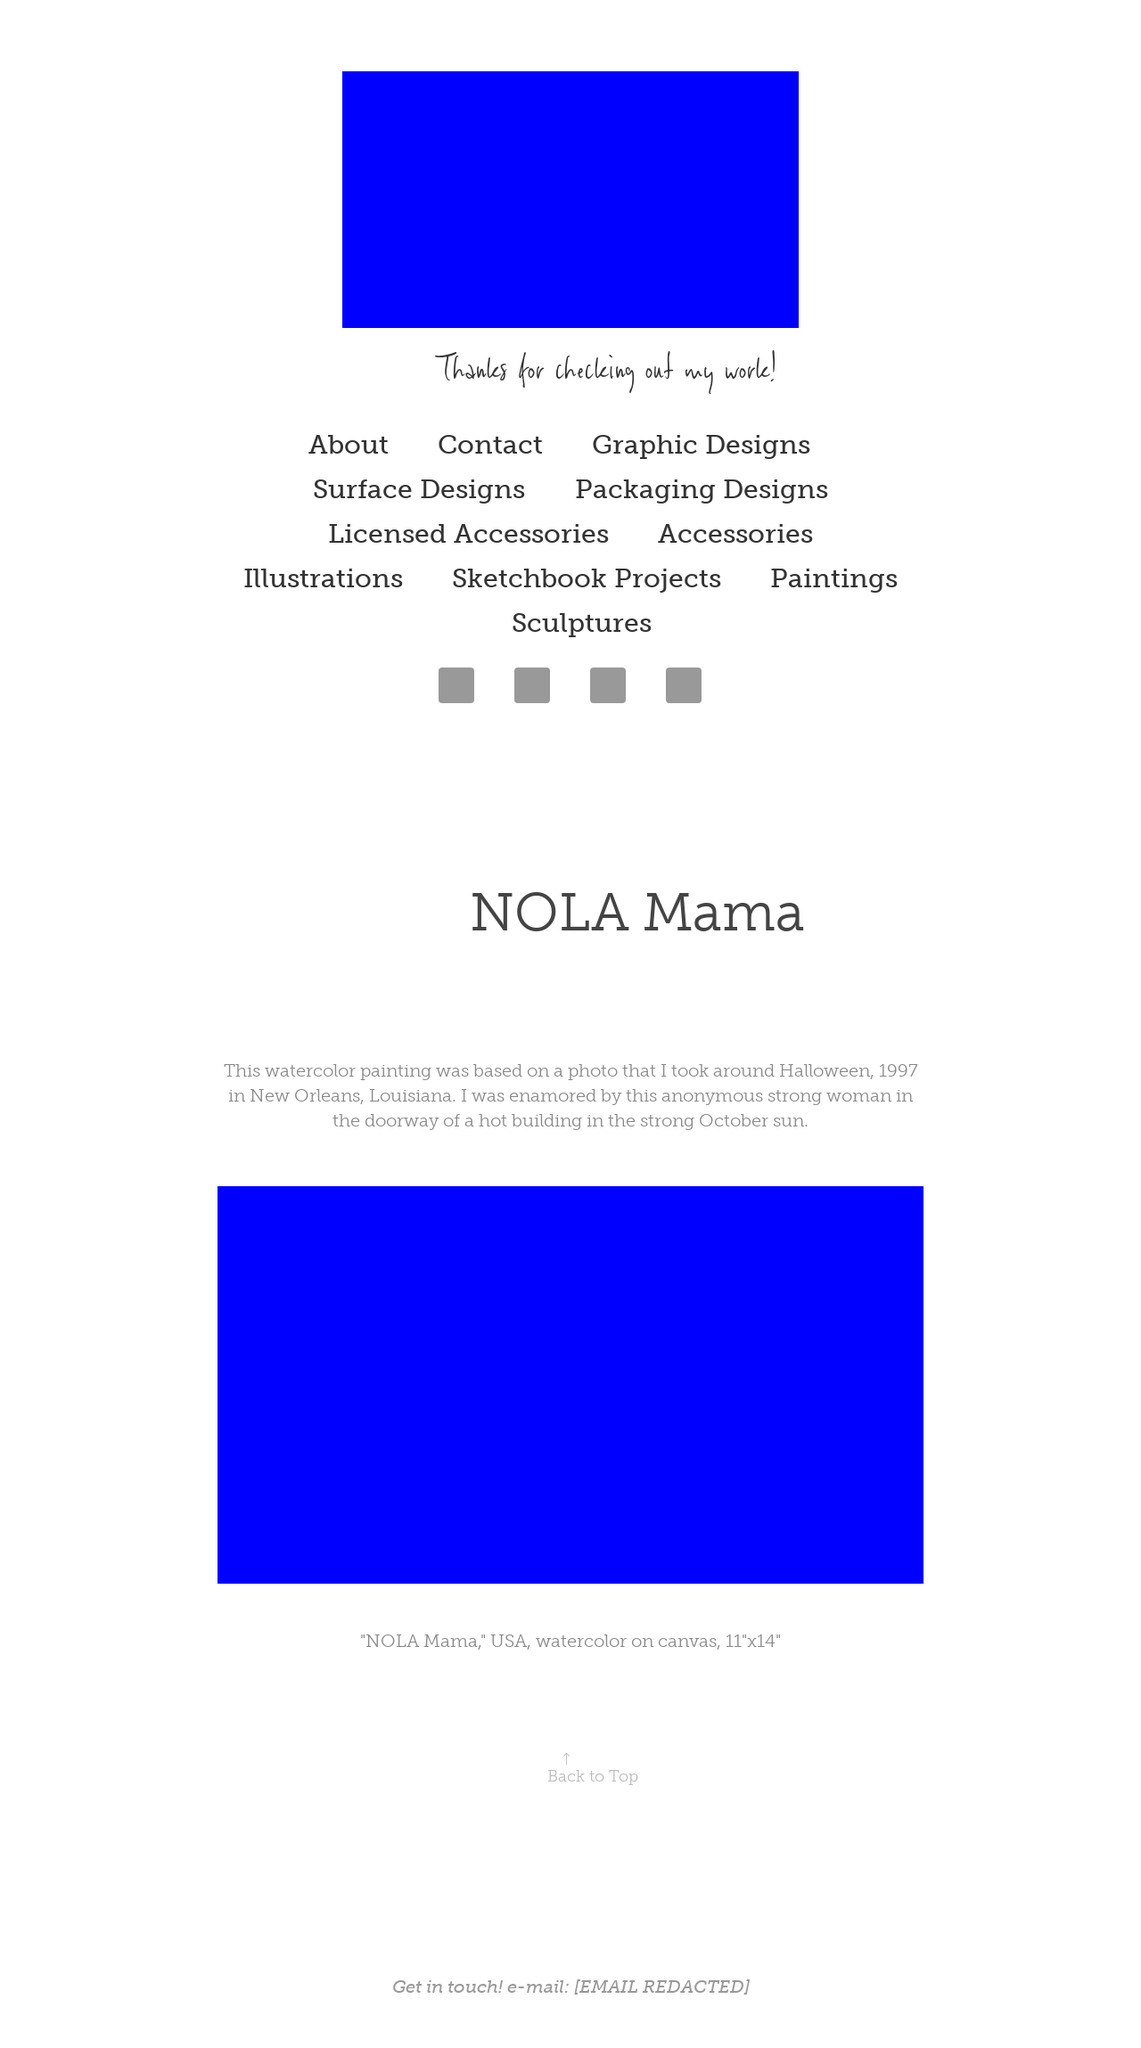Can you describe the theme and artistic elements observed in this image? The image features a website portfolio that provides an insight into various creative works categorized under sections like Graphic Designs, Surface Designs, and Paintings. It has a minimalist design with a spacious layout, enhancing focus on the content. The prominent use of blue at the top symbolizes calm and depth, which might hint at the creative depth of the displayed works. The overall aesthetic is clean with the use of modern typography and structured navigation, aimed at showcasing the artist's professional scope and artistic sensibilities. 